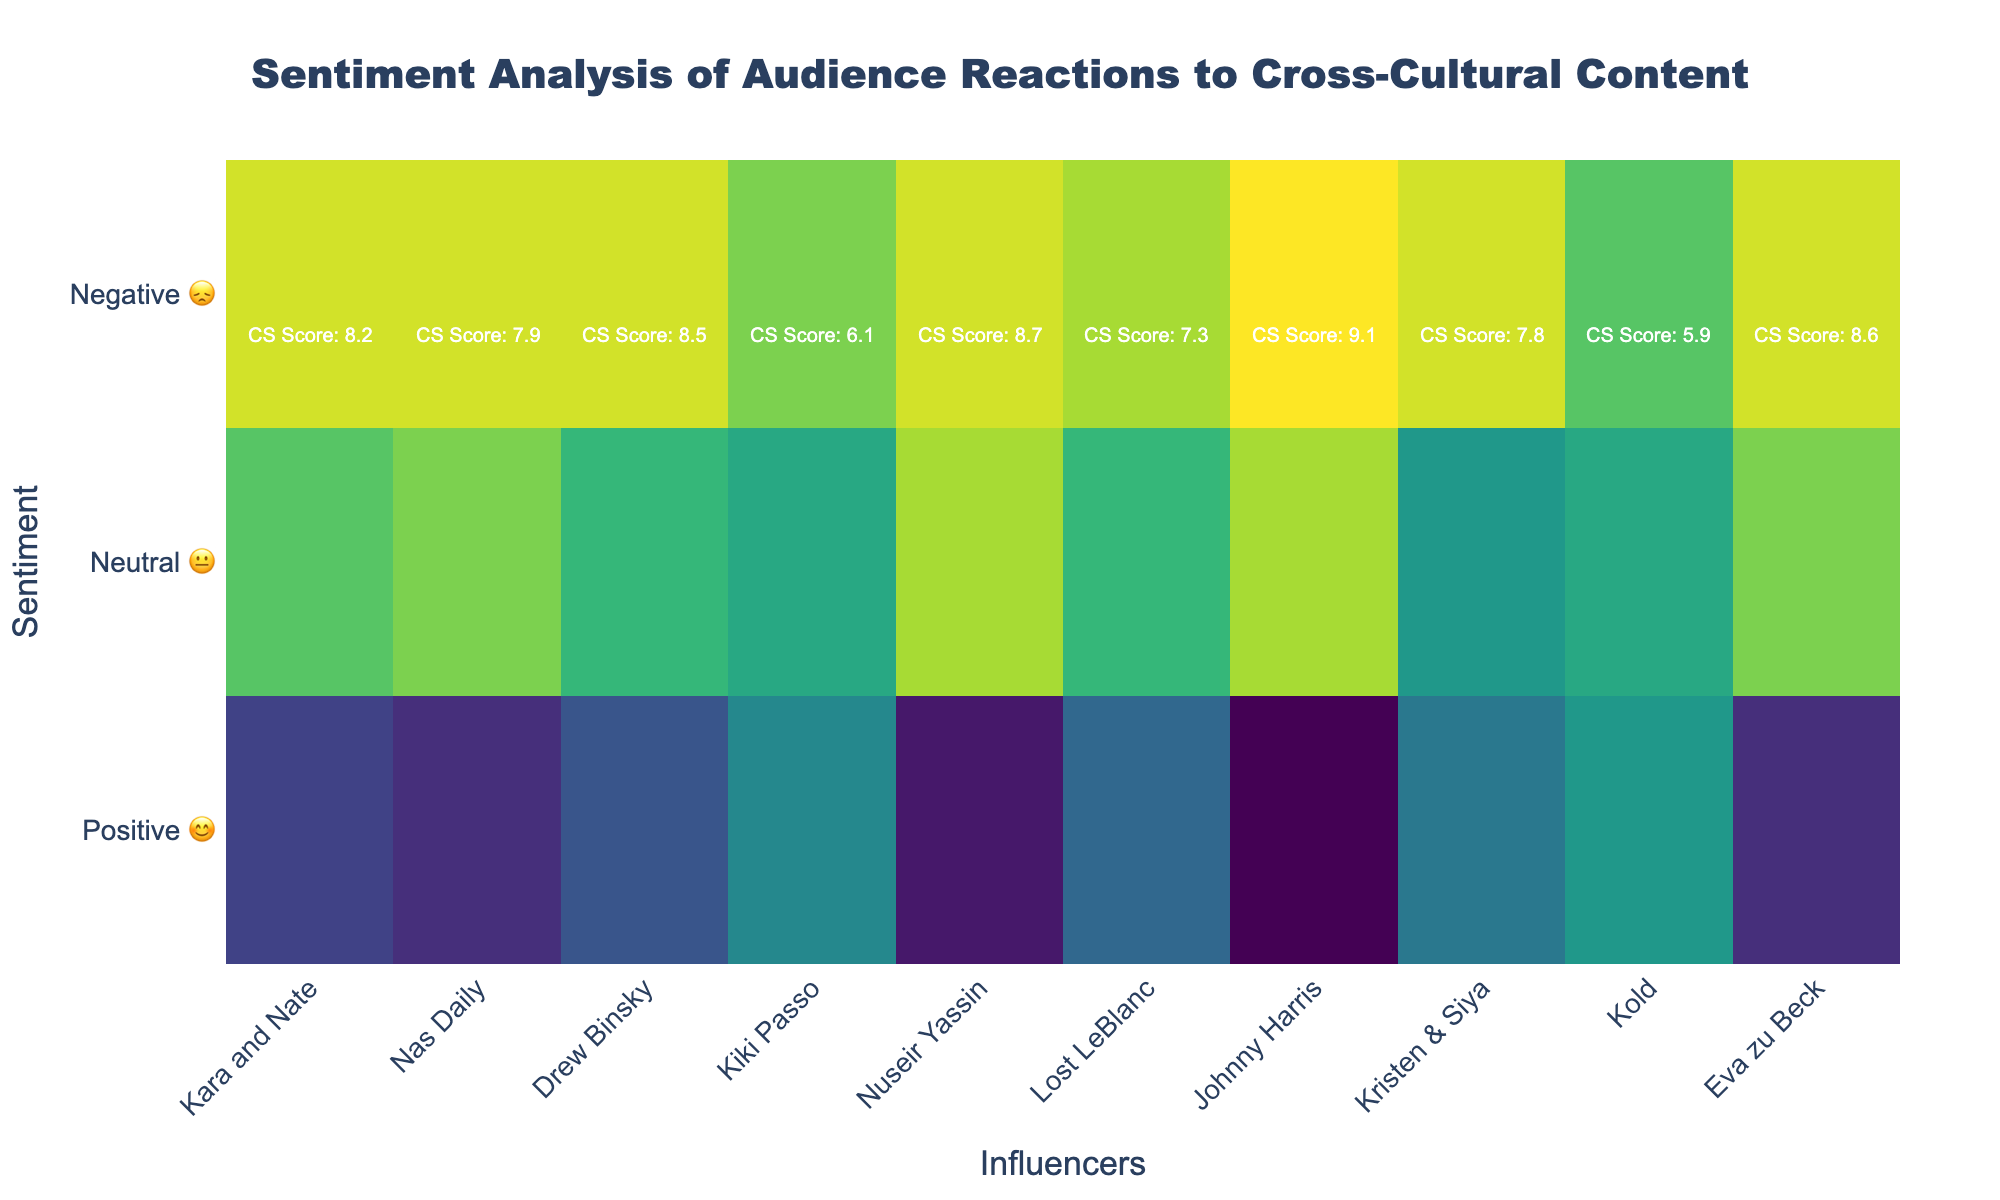What is the percentage of positive sentiment for Johnny Harris? The positive sentiment for Johnny Harris is depicted on the y-axis labeled "Positive 😊". Look at the value corresponding to Johnny Harris on this row.
Answer: 80% Which influencer has the highest cultural sensitivity score? Check the annotations on the heatmap which display "CS Score" for each influencer. Compare all the scores to find the highest one.
Answer: Johnny Harris Compare the percentage of positive sentiment for Kara and Nate with Drew Binsky. Who has a higher percentage? Compare the values corresponding to Kara and Nate and Drew Binsky under the "Positive 😊" row.
Answer: Kara and Nate What is the total percentage of neutral sentiment for the top three influencers in terms of cultural sensitivity score? Identify the top three influencers based on their cultural sensitivity scores. Sum their neutral sentiment percentages. The top three influencers are Johnny Harris, Nuseir Yassin, and Eva zu Beck (`15 + 15 + 20`).
Answer: 50% Who has the lowest percentage of positive sentiment, and what is that percentage? Look at the "Positive 😊" row and identify the lowest value and its corresponding influencer.
Answer: Kold, 40% Which influencer has the highest negative sentiment percentage, and what is that percentage? Check the "Negative 😞" row and find the highest value, noting the corresponding influencer.
Answer: Kold, 25% How many influencers have a cultural sensitivity score above 8? Count the number of influencers with cultural sensitivity scores greater than 8.
Answer: 5 How does Nuseir Yassin's positive sentiment percentage compare to Nas Daily's? Look at the "Positive 😊" row and compare Nuseir Yassin's and Nas Daily's values.
Answer: Nuseir Yassin has 5% more positive sentiment than Nas Daily Considering only influencers with negative sentiment percentages of 10%, who has the highest cultural sensitivity score? Filter out influencers with 10% negative sentiment and then compare their cultural sensitivity scores.
Answer: Eva zu Beck What is the difference in neutral sentiment between Kiki Passo and Kristen & Siya? Look at the "Neutral 😐" row and find the difference between the values for Kiki Passo and Kristen & Siya (`40 - 35`).
Answer: 5% 